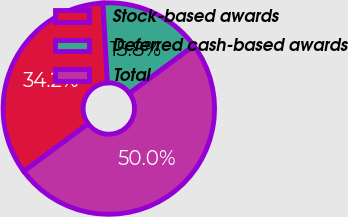<chart> <loc_0><loc_0><loc_500><loc_500><pie_chart><fcel>Stock-based awards<fcel>Deferred cash-based awards<fcel>Total<nl><fcel>34.24%<fcel>15.76%<fcel>50.0%<nl></chart> 